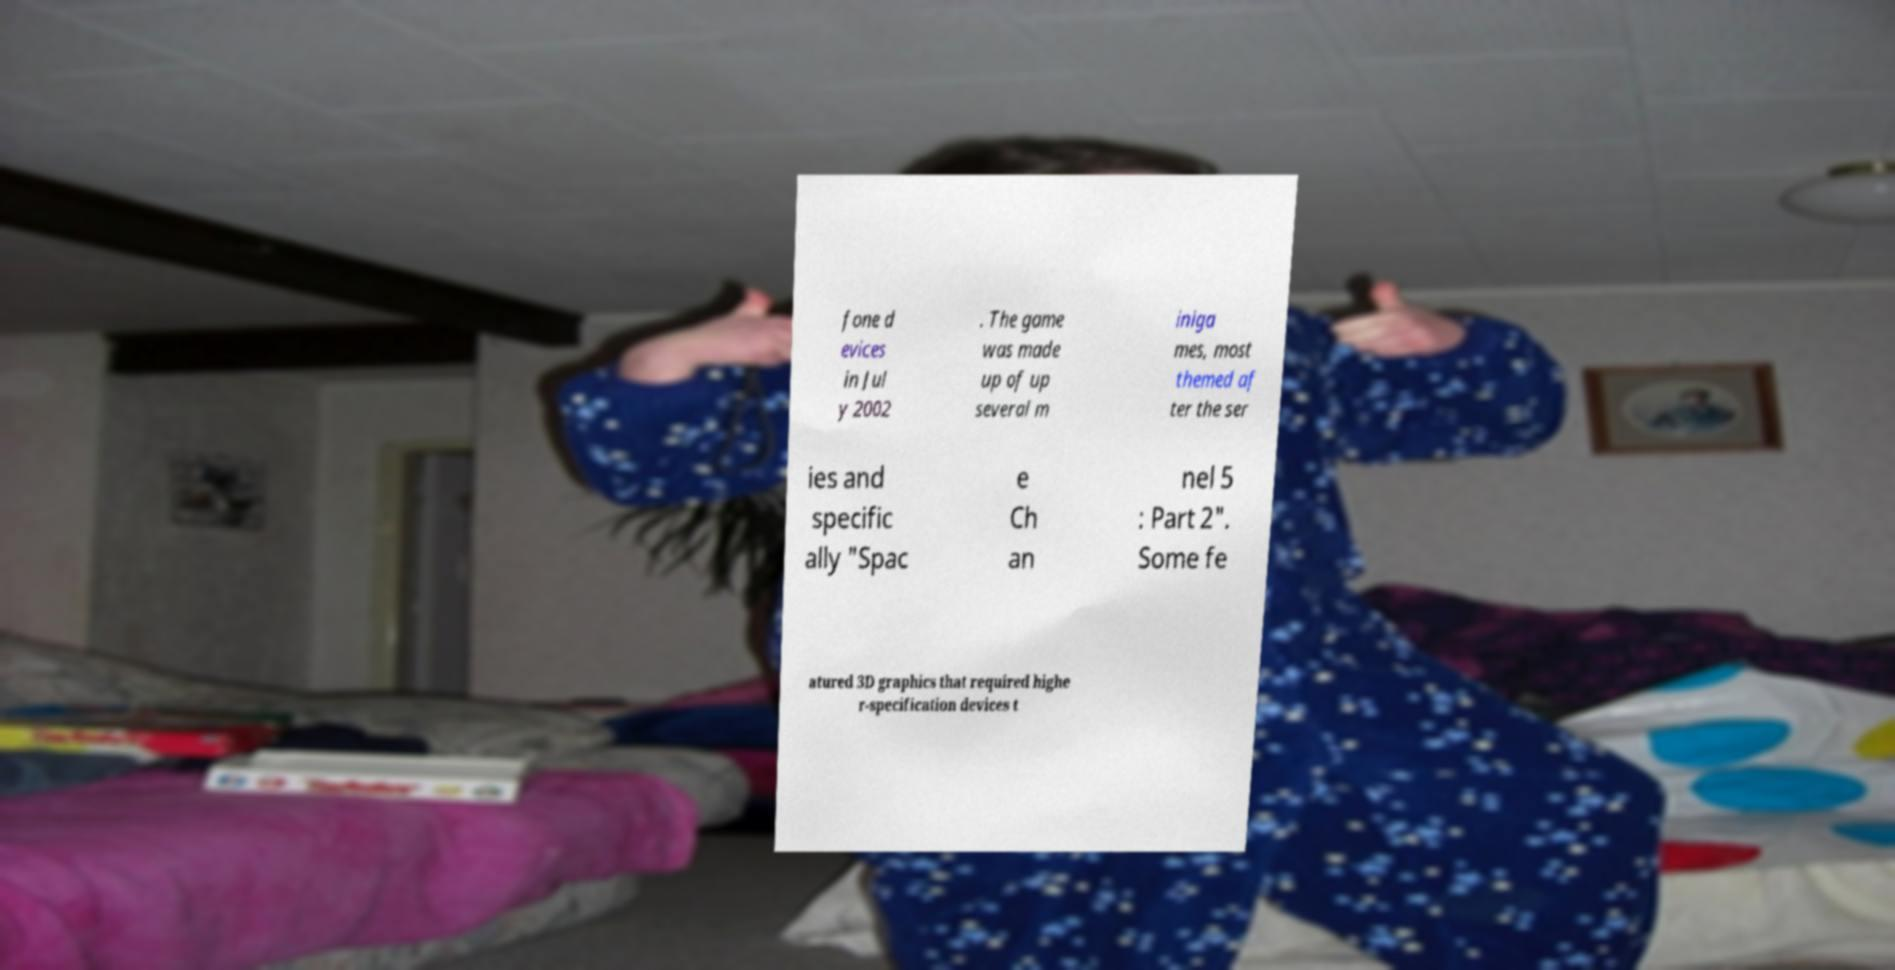What messages or text are displayed in this image? I need them in a readable, typed format. fone d evices in Jul y 2002 . The game was made up of up several m iniga mes, most themed af ter the ser ies and specific ally "Spac e Ch an nel 5 : Part 2". Some fe atured 3D graphics that required highe r-specification devices t 